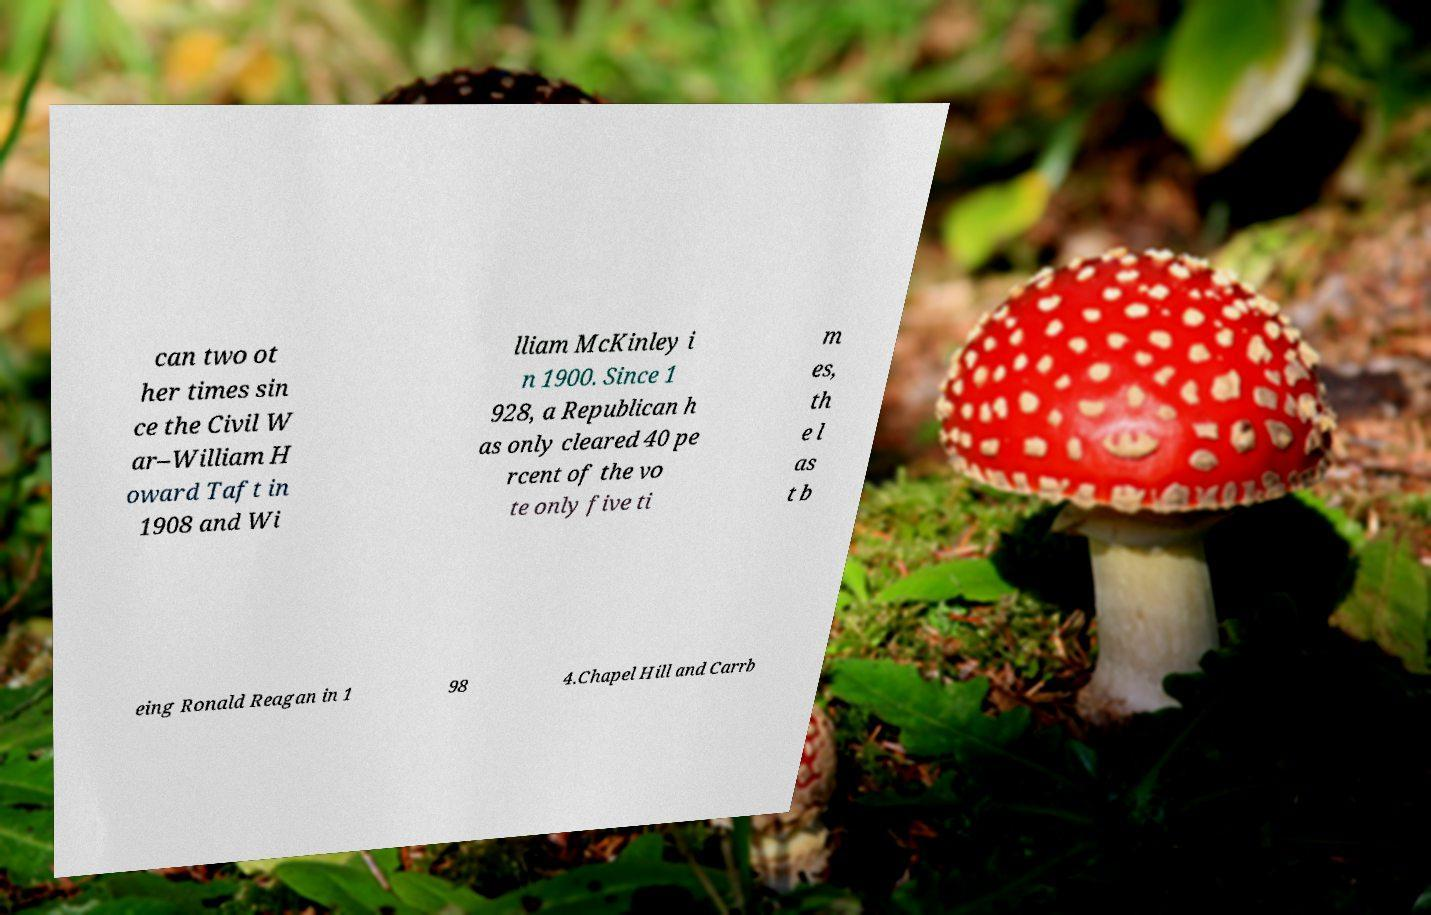What messages or text are displayed in this image? I need them in a readable, typed format. can two ot her times sin ce the Civil W ar–William H oward Taft in 1908 and Wi lliam McKinley i n 1900. Since 1 928, a Republican h as only cleared 40 pe rcent of the vo te only five ti m es, th e l as t b eing Ronald Reagan in 1 98 4.Chapel Hill and Carrb 